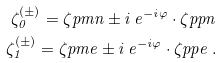<formula> <loc_0><loc_0><loc_500><loc_500>\zeta _ { 0 } ^ { ( \pm ) } = \zeta p m n \pm i \, e ^ { - i \varphi } \cdot \zeta p p n \\ \zeta _ { 1 } ^ { ( \pm ) } = \zeta p m e \pm i \, e ^ { - i \varphi } \cdot \zeta p p e \ .</formula> 